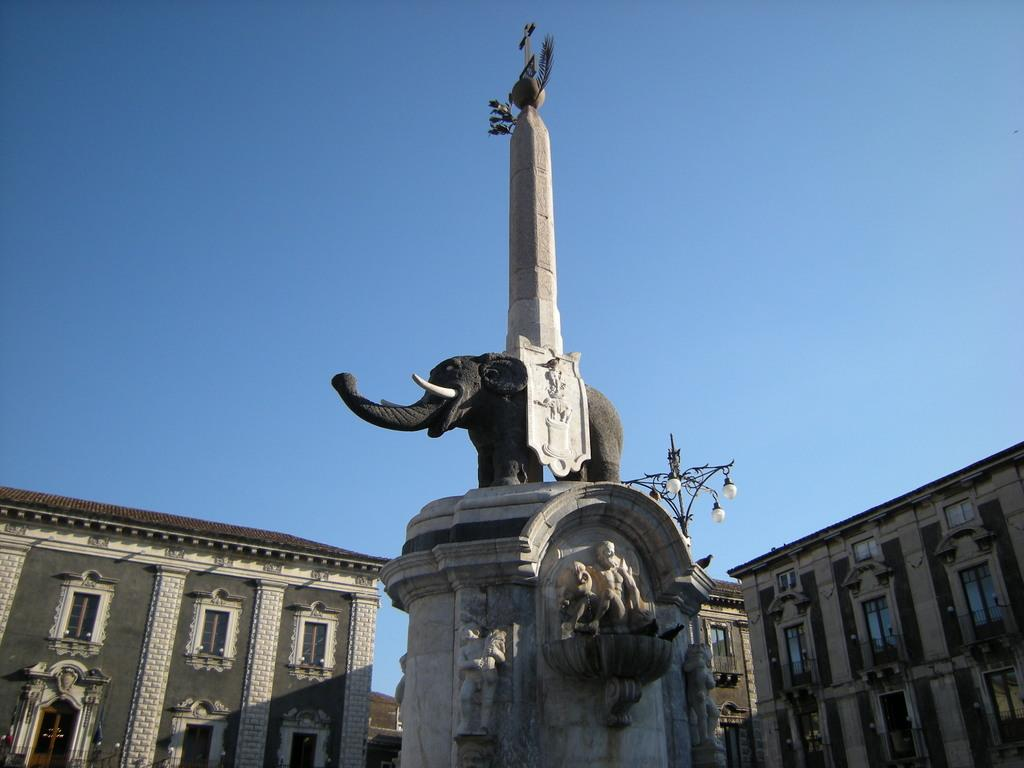What type of structures are present in the image? There are buildings in the image. How many windows can be seen in the image? There are multiple windows visible in the image. What type of artwork is present in the image? There are sculptures in the image. What type of illumination is present in the image? There are lights in the image. What can be seen in the background of the image? The sky is visible in the background of the image. Can you tell me how many giraffes are standing on the bed in the image? There are no giraffes or beds present in the image. 